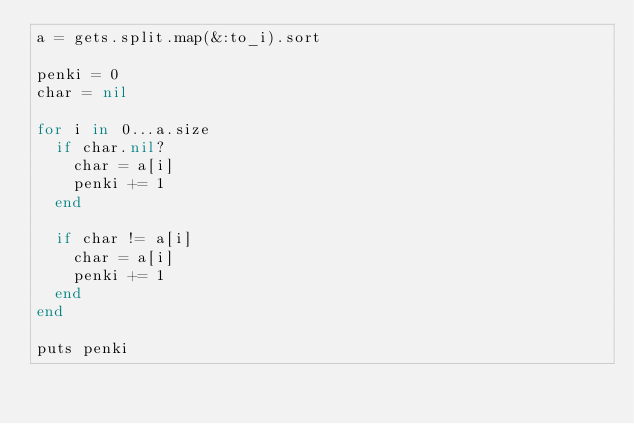Convert code to text. <code><loc_0><loc_0><loc_500><loc_500><_Ruby_>a = gets.split.map(&:to_i).sort

penki = 0
char = nil

for i in 0...a.size
	if char.nil?
		char = a[i]
		penki += 1
	end

	if char != a[i]
		char = a[i]
		penki += 1
	end
end

puts penki</code> 